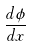Convert formula to latex. <formula><loc_0><loc_0><loc_500><loc_500>\frac { d \phi } { d x }</formula> 